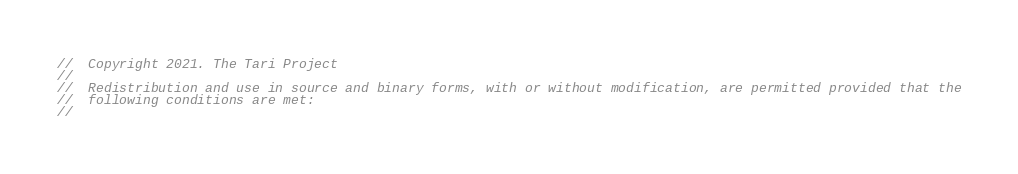<code> <loc_0><loc_0><loc_500><loc_500><_Rust_>//  Copyright 2021. The Tari Project
//
//  Redistribution and use in source and binary forms, with or without modification, are permitted provided that the
//  following conditions are met:
//</code> 